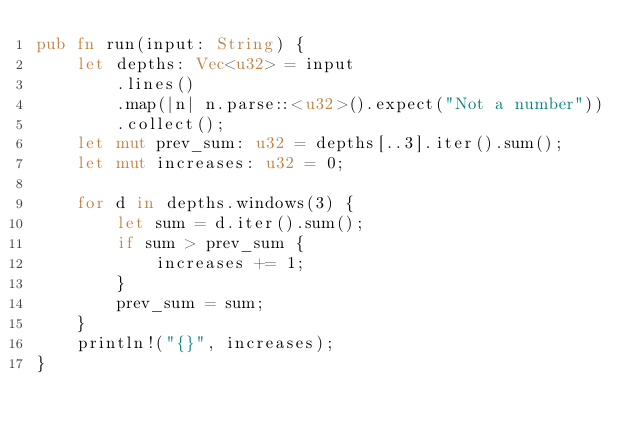<code> <loc_0><loc_0><loc_500><loc_500><_Rust_>pub fn run(input: String) {
    let depths: Vec<u32> = input
        .lines()
        .map(|n| n.parse::<u32>().expect("Not a number"))
        .collect();
    let mut prev_sum: u32 = depths[..3].iter().sum();
    let mut increases: u32 = 0;

    for d in depths.windows(3) {
        let sum = d.iter().sum();
        if sum > prev_sum {
            increases += 1;
        }
        prev_sum = sum;
    }
    println!("{}", increases);
}
</code> 